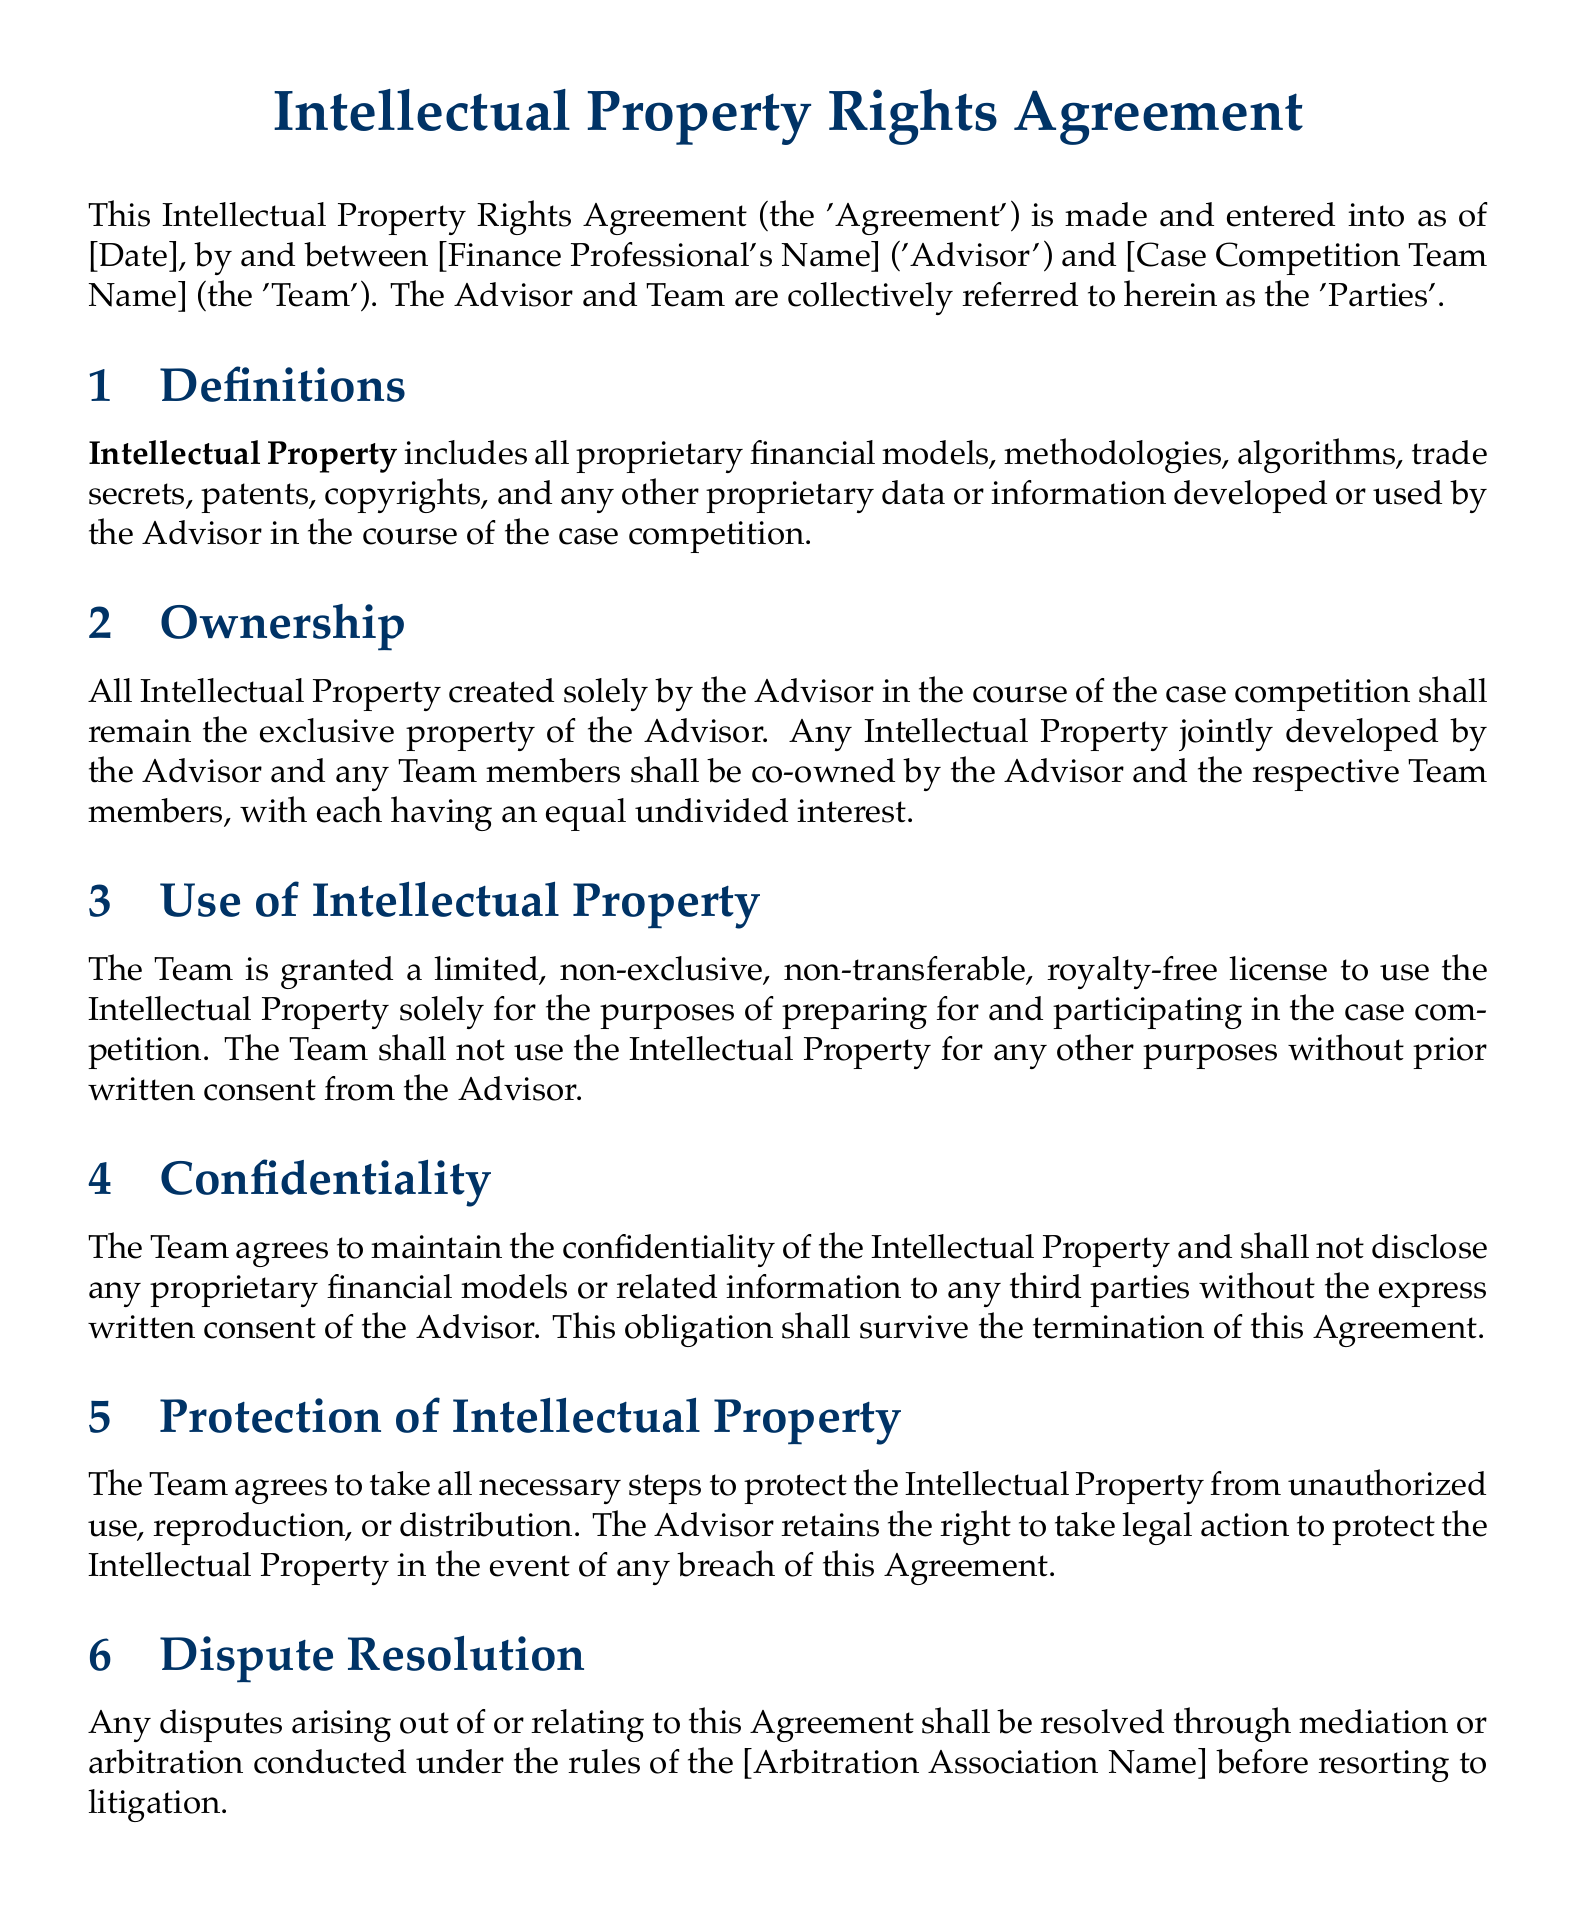What is the title of the document? The title is prominently displayed at the top of the document.
Answer: Intellectual Property Rights Agreement Who are the parties involved in the agreement? The parties are defined in the introduction of the document.
Answer: Advisor and Team What does "Intellectual Property" include according to the agreement? The document specifies what constitutes Intellectual Property in the definitions section.
Answer: Proprietary financial models, methodologies, algorithms, trade secrets, patents, copyrights What type of license is granted to the Team? This is mentioned in the section outlining the use of Intellectual Property.
Answer: Limited, non-exclusive, non-transferable, royalty-free license What is the governing law stated in the agreement? The governing law is specified towards the end of the document.
Answer: The laws of the State of [State Name] What must the Team do to protect the Intellectual Property? The document outlines the responsibilities of the Team in the section regarding protection.
Answer: Take all necessary steps to protect What happens if disputes arise according to the agreement? The dispute resolution procedure is stated in the relevant section.
Answer: Mediation or arbitration What is required for the Team to disclose any proprietary information? The confidentiality section outlines the conditions regarding disclosure.
Answer: Express written consent of the Advisor 